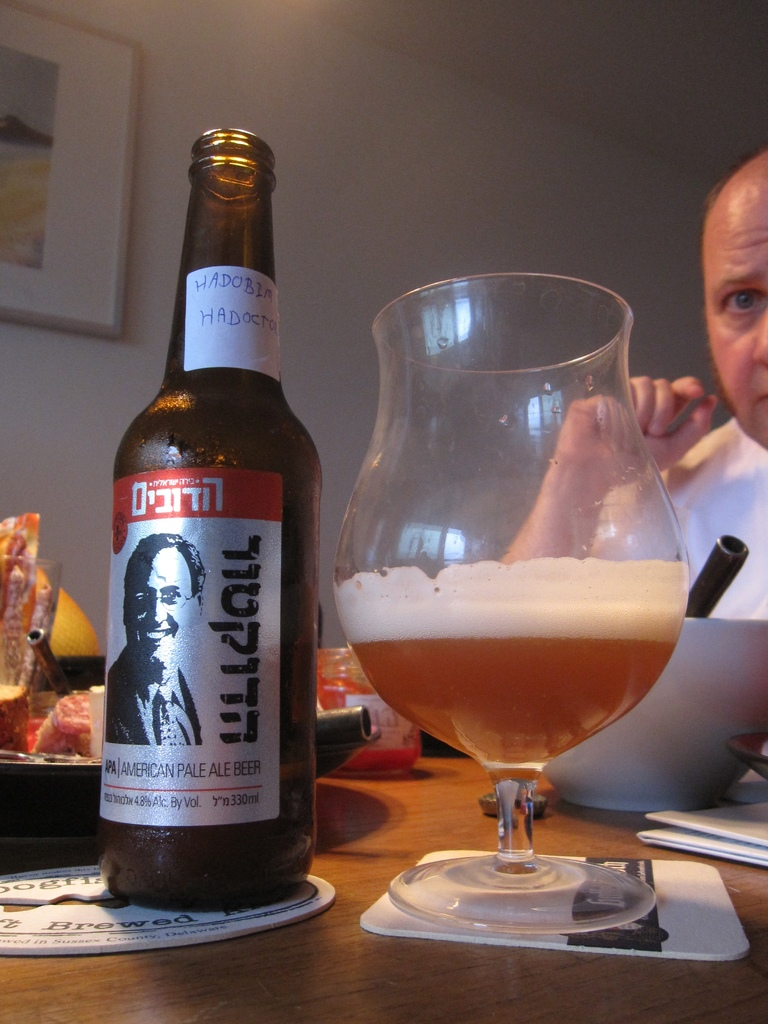Provide a one-sentence caption for the provided image. A focused man enjoys his meal in a cozy dining setting, savoring a chilled glass of American Pale Ale, capturing a relaxed and personal moment. 